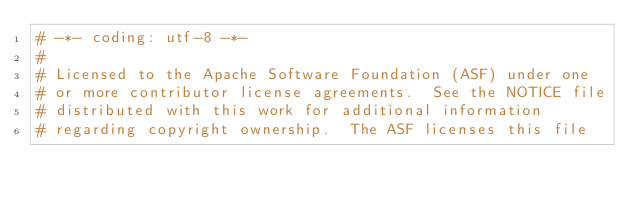Convert code to text. <code><loc_0><loc_0><loc_500><loc_500><_Python_># -*- coding: utf-8 -*-
#
# Licensed to the Apache Software Foundation (ASF) under one
# or more contributor license agreements.  See the NOTICE file
# distributed with this work for additional information
# regarding copyright ownership.  The ASF licenses this file</code> 